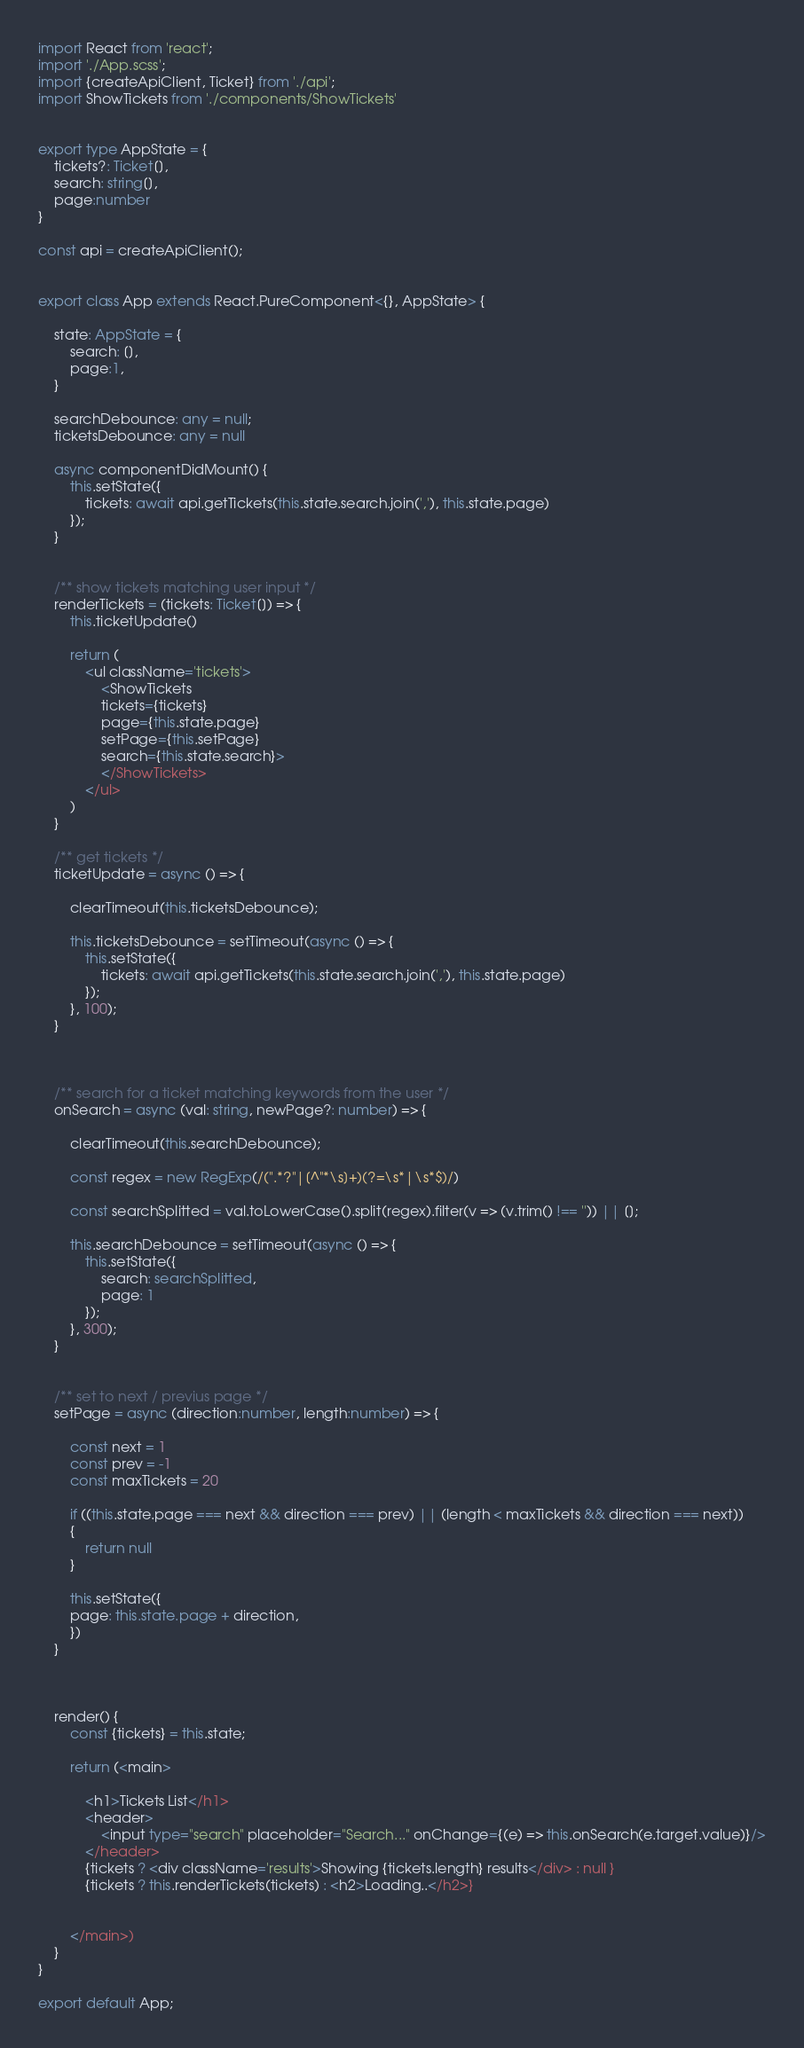Convert code to text. <code><loc_0><loc_0><loc_500><loc_500><_TypeScript_>import React from 'react';
import './App.scss';
import {createApiClient, Ticket} from './api';
import ShowTickets from './components/ShowTickets'


export type AppState = {
	tickets?: Ticket[],
	search: string[],
	page:number
}

const api = createApiClient();


export class App extends React.PureComponent<{}, AppState> {

	state: AppState = {
		search: [],
		page:1,
	}

	searchDebounce: any = null;
	ticketsDebounce: any = null

	async componentDidMount() {
		this.setState({
			tickets: await api.getTickets(this.state.search.join(','), this.state.page)
		});
	}


	/** show tickets matching user input */
	renderTickets = (tickets: Ticket[]) => {
		this.ticketUpdate()
		
		return (
			<ul className='tickets'>
				<ShowTickets 
				tickets={tickets} 
				page={this.state.page} 
				setPage={this.setPage}
				search={this.state.search}>
				</ShowTickets>
			</ul>
		)
	}

	/** get tickets */
	ticketUpdate = async () => {

		clearTimeout(this.ticketsDebounce);

		this.ticketsDebounce = setTimeout(async () => {
			this.setState({
				tickets: await api.getTickets(this.state.search.join(','), this.state.page)
			});
		}, 100);
	}


 
	/** search for a ticket matching keywords from the user */
	onSearch = async (val: string, newPage?: number) => {
		
		clearTimeout(this.searchDebounce);

		const regex = new RegExp(/(".*?"|[^"*\s]+)(?=\s*|\s*$)/)

		const searchSplitted = val.toLowerCase().split(regex).filter(v => (v.trim() !== '')) || [];
		
		this.searchDebounce = setTimeout(async () => {
			this.setState({
				search: searchSplitted,
				page: 1
			});
		}, 300);
	}


	/** set to next / previus page */
	setPage = async (direction:number, length:number) => {
		
		const next = 1
		const prev = -1
		const maxTickets = 20

		if ((this.state.page === next && direction === prev) || (length < maxTickets && direction === next))
		{
			return null
		}
		
		this.setState({
		page: this.state.page + direction,
		})	
	}

	

	render() {	
		const {tickets} = this.state;

		return (<main>
			
			<h1>Tickets List</h1>
			<header>
				<input type="search" placeholder="Search..." onChange={(e) => this.onSearch(e.target.value)}/>
			</header>
			{tickets ? <div className='results'>Showing {tickets.length} results</div> : null }	
			{tickets ? this.renderTickets(tickets) : <h2>Loading..</h2>}
			
			
		</main>)
	}
}

export default App;</code> 